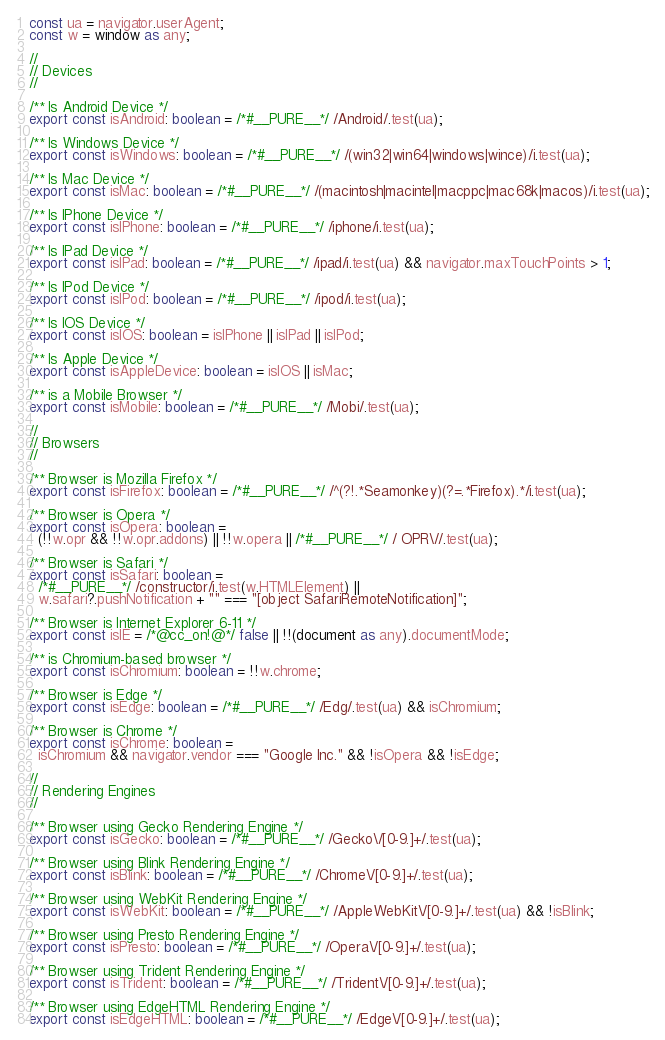Convert code to text. <code><loc_0><loc_0><loc_500><loc_500><_TypeScript_>const ua = navigator.userAgent;
const w = window as any;

//
// Devices
//

/** Is Android Device */
export const isAndroid: boolean = /*#__PURE__*/ /Android/.test(ua);

/** Is Windows Device */
export const isWindows: boolean = /*#__PURE__*/ /(win32|win64|windows|wince)/i.test(ua);

/** Is Mac Device */
export const isMac: boolean = /*#__PURE__*/ /(macintosh|macintel|macppc|mac68k|macos)/i.test(ua);

/** Is IPhone Device */
export const isIPhone: boolean = /*#__PURE__*/ /iphone/i.test(ua);

/** Is IPad Device */
export const isIPad: boolean = /*#__PURE__*/ /ipad/i.test(ua) && navigator.maxTouchPoints > 1;

/** Is IPod Device */
export const isIPod: boolean = /*#__PURE__*/ /ipod/i.test(ua);

/** Is IOS Device */
export const isIOS: boolean = isIPhone || isIPad || isIPod;

/** Is Apple Device */
export const isAppleDevice: boolean = isIOS || isMac;

/** is a Mobile Browser */
export const isMobile: boolean = /*#__PURE__*/ /Mobi/.test(ua);

//
// Browsers
//

/** Browser is Mozilla Firefox */
export const isFirefox: boolean = /*#__PURE__*/ /^(?!.*Seamonkey)(?=.*Firefox).*/i.test(ua);

/** Browser is Opera */
export const isOpera: boolean =
  (!!w.opr && !!w.opr.addons) || !!w.opera || /*#__PURE__*/ / OPR\//.test(ua);

/** Browser is Safari */
export const isSafari: boolean =
  /*#__PURE__*/ /constructor/i.test(w.HTMLElement) ||
  w.safari?.pushNotification + "" === "[object SafariRemoteNotification]";

/** Browser is Internet Explorer 6-11 */
export const isIE = /*@cc_on!@*/ false || !!(document as any).documentMode;

/** is Chromium-based browser */
export const isChromium: boolean = !!w.chrome;

/** Browser is Edge */
export const isEdge: boolean = /*#__PURE__*/ /Edg/.test(ua) && isChromium;

/** Browser is Chrome */
export const isChrome: boolean =
  isChromium && navigator.vendor === "Google Inc." && !isOpera && !isEdge;

//
// Rendering Engines
//

/** Browser using Gecko Rendering Engine */
export const isGecko: boolean = /*#__PURE__*/ /Gecko\/[0-9.]+/.test(ua);

/** Browser using Blink Rendering Engine */
export const isBlink: boolean = /*#__PURE__*/ /Chrome\/[0-9.]+/.test(ua);

/** Browser using WebKit Rendering Engine */
export const isWebKit: boolean = /*#__PURE__*/ /AppleWebKit\/[0-9.]+/.test(ua) && !isBlink;

/** Browser using Presto Rendering Engine */
export const isPresto: boolean = /*#__PURE__*/ /Opera\/[0-9.]+/.test(ua);

/** Browser using Trident Rendering Engine */
export const isTrident: boolean = /*#__PURE__*/ /Trident\/[0-9.]+/.test(ua);

/** Browser using EdgeHTML Rendering Engine */
export const isEdgeHTML: boolean = /*#__PURE__*/ /Edge\/[0-9.]+/.test(ua);
</code> 